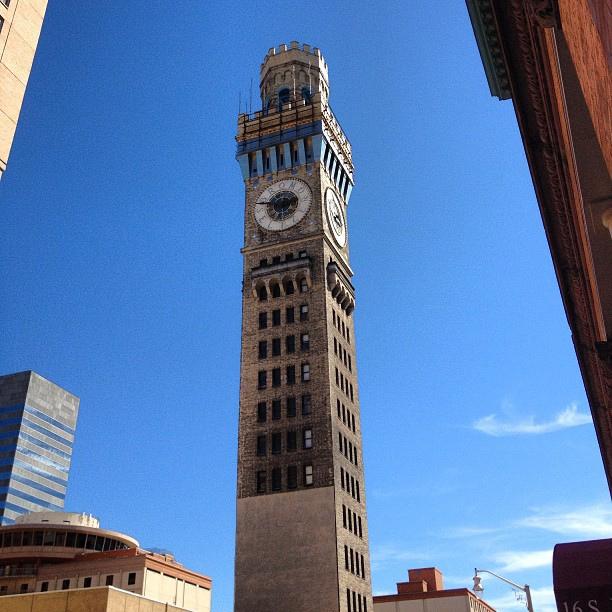What kind of setting is this area?
Write a very short answer. City. Is that time correct?
Write a very short answer. Yes. Is there a clock on this building?
Be succinct. Yes. 